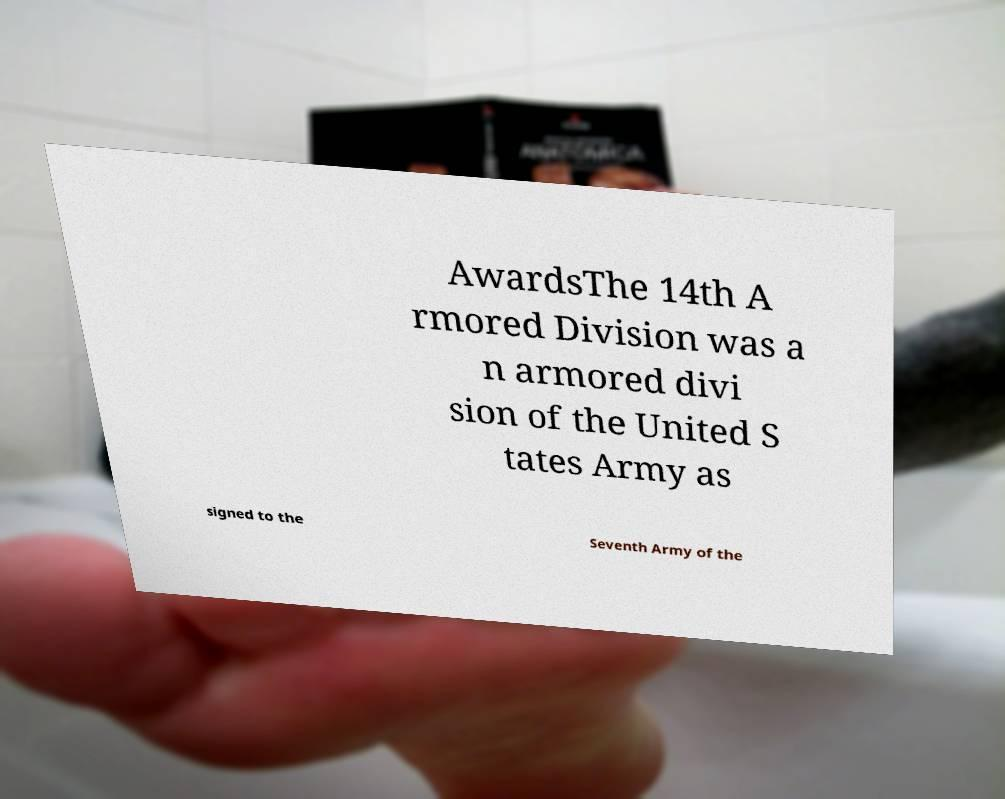What messages or text are displayed in this image? I need them in a readable, typed format. AwardsThe 14th A rmored Division was a n armored divi sion of the United S tates Army as signed to the Seventh Army of the 